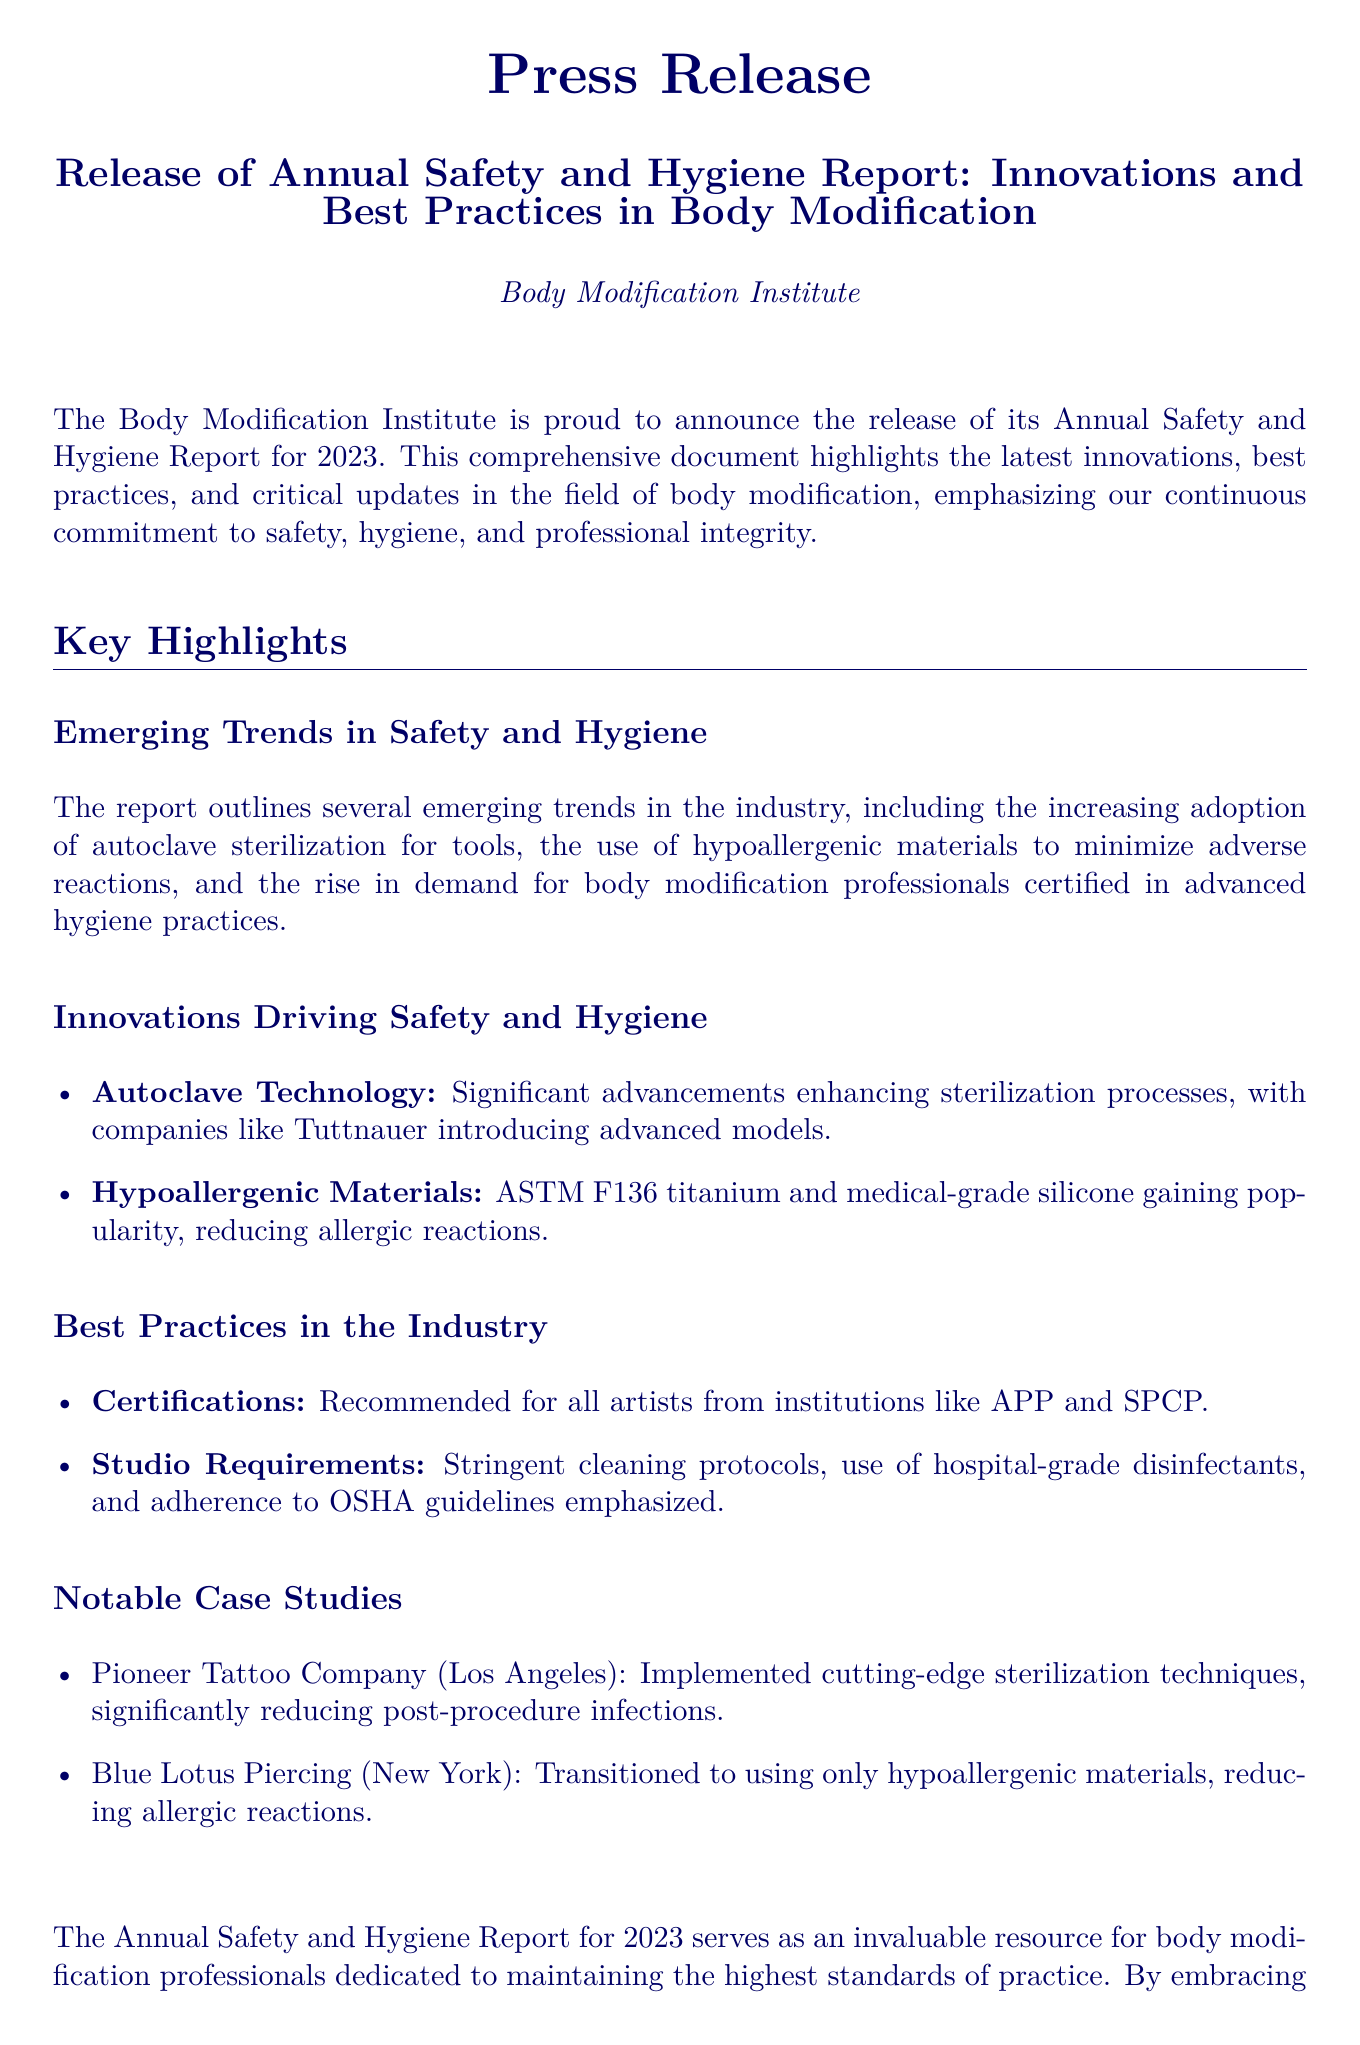What is the name of the institution releasing the report? The report is released by the Body Modification Institute.
Answer: Body Modification Institute What year does the Annual Safety and Hygiene Report pertain to? The report discusses developments and practices specific to the year 2023.
Answer: 2023 Which sterilization technology is highlighted in the report? The report mentions significant advancements in autoclave sterilization technologies.
Answer: Autoclave Technology What type of materials are recommended to minimize adverse reactions? Hypoallergenic materials like ASTM F136 titanium are emphasized in the report.
Answer: Hypoallergenic materials Which two case studies are mentioned in the report? The report includes case studies from Pioneer Tattoo Company and Blue Lotus Piercing.
Answer: Pioneer Tattoo Company and Blue Lotus Piercing What do the best practices in the industry include according to the report? Certifications for artists and stringent cleaning protocols are included as best practices.
Answer: Certifications and cleaning protocols What is the purpose of the Annual Safety and Hygiene Report? The report serves as a resource to maintain high standards of practice for body modification professionals.
Answer: Maintain high standards of practice How does the report suggest reducing allergic reactions? By transitioning to using only hypoallergenic materials.
Answer: Using only hypoallergenic materials What organization's certifications are recommended for body modification artists? Certifications are recommended from institutions like APP and SPCP.
Answer: APP and SPCP 